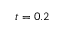Convert formula to latex. <formula><loc_0><loc_0><loc_500><loc_500>t = 0 . 2</formula> 